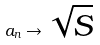<formula> <loc_0><loc_0><loc_500><loc_500>a _ { n } \rightarrow \sqrt { S }</formula> 